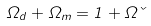<formula> <loc_0><loc_0><loc_500><loc_500>\Omega _ { d } + \Omega _ { m } = 1 + \Omega \kappa</formula> 